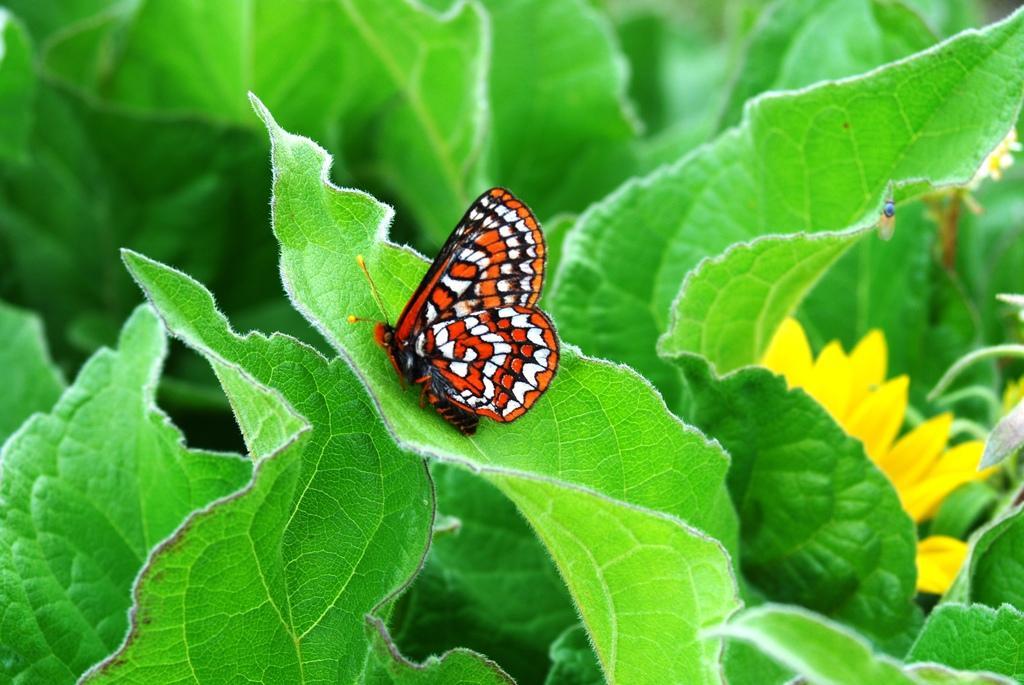How would you summarize this image in a sentence or two? In the image there is a butterfly laying on a leaf and around that leaf there are many other leaves. 